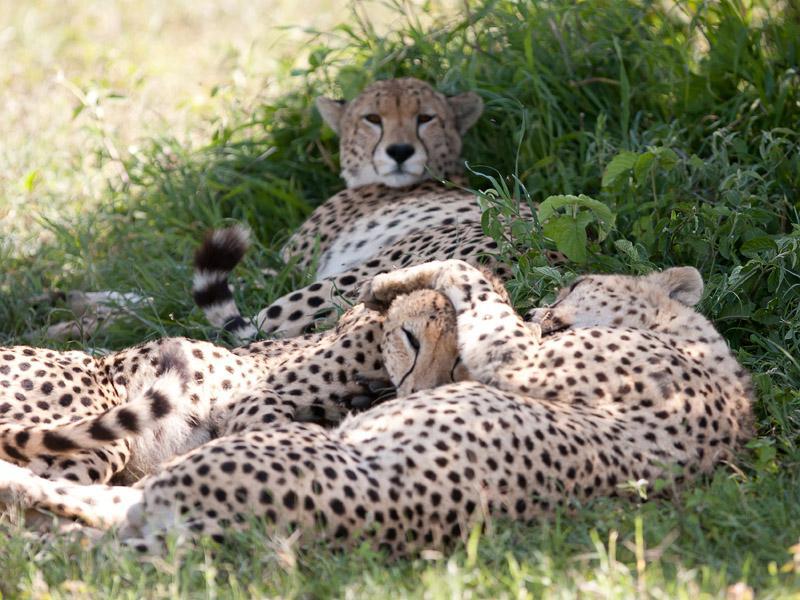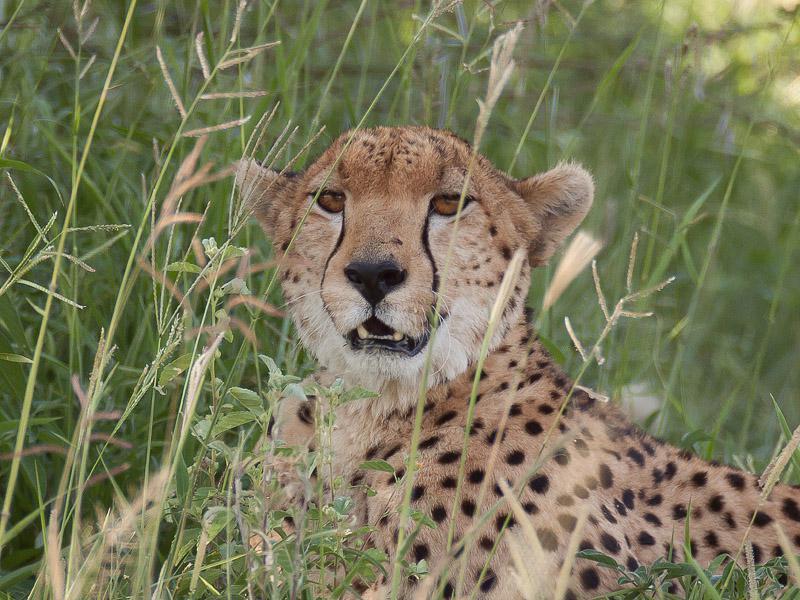The first image is the image on the left, the second image is the image on the right. Examine the images to the left and right. Is the description "There are 5 or more cheetahs." accurate? Answer yes or no. No. The first image is the image on the left, the second image is the image on the right. For the images displayed, is the sentence "There are at least two leopards laying down on their sides together in one of the images." factually correct? Answer yes or no. Yes. 